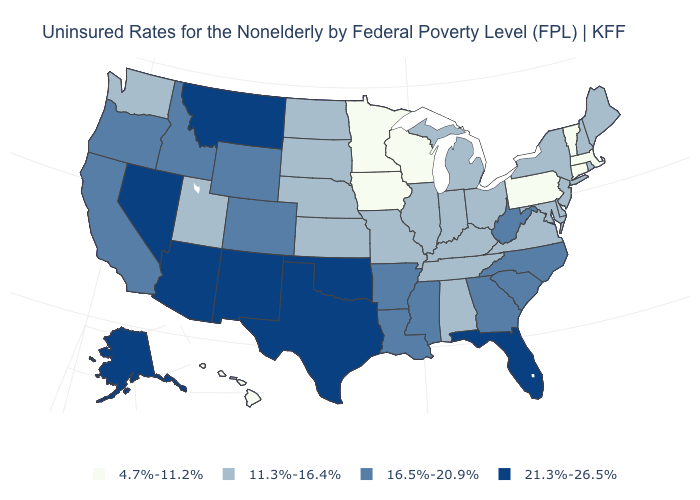Which states hav the highest value in the West?
Be succinct. Alaska, Arizona, Montana, Nevada, New Mexico. What is the value of New York?
Be succinct. 11.3%-16.4%. Does Delaware have a lower value than Nebraska?
Write a very short answer. No. Name the states that have a value in the range 11.3%-16.4%?
Answer briefly. Alabama, Delaware, Illinois, Indiana, Kansas, Kentucky, Maine, Maryland, Michigan, Missouri, Nebraska, New Hampshire, New Jersey, New York, North Dakota, Ohio, Rhode Island, South Dakota, Tennessee, Utah, Virginia, Washington. What is the value of Arkansas?
Keep it brief. 16.5%-20.9%. Does Maine have the lowest value in the Northeast?
Short answer required. No. Name the states that have a value in the range 4.7%-11.2%?
Answer briefly. Connecticut, Hawaii, Iowa, Massachusetts, Minnesota, Pennsylvania, Vermont, Wisconsin. Among the states that border Nebraska , which have the lowest value?
Quick response, please. Iowa. Does Wisconsin have the highest value in the MidWest?
Write a very short answer. No. What is the value of Oklahoma?
Keep it brief. 21.3%-26.5%. Is the legend a continuous bar?
Quick response, please. No. Does Connecticut have the highest value in the USA?
Give a very brief answer. No. What is the value of Iowa?
Concise answer only. 4.7%-11.2%. What is the value of Alabama?
Write a very short answer. 11.3%-16.4%. 